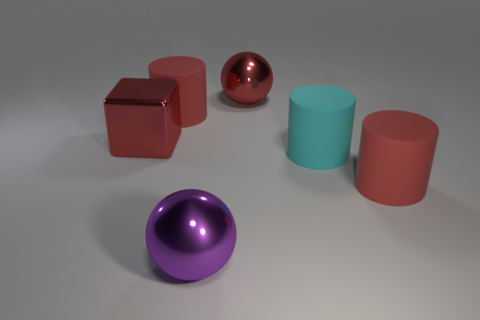Subtract all cyan matte cylinders. How many cylinders are left? 2 Subtract all cyan balls. How many red cylinders are left? 2 Add 4 small gray things. How many objects exist? 10 Subtract all cyan cylinders. How many cylinders are left? 2 Subtract all spheres. How many objects are left? 4 Subtract all green cylinders. Subtract all red balls. How many cylinders are left? 3 Add 6 big red balls. How many big red balls exist? 7 Subtract 0 yellow balls. How many objects are left? 6 Subtract all red cubes. Subtract all cylinders. How many objects are left? 2 Add 3 large red cubes. How many large red cubes are left? 4 